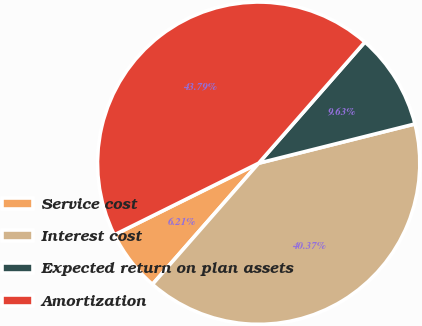Convert chart to OTSL. <chart><loc_0><loc_0><loc_500><loc_500><pie_chart><fcel>Service cost<fcel>Interest cost<fcel>Expected return on plan assets<fcel>Amortization<nl><fcel>6.21%<fcel>40.37%<fcel>9.63%<fcel>43.79%<nl></chart> 